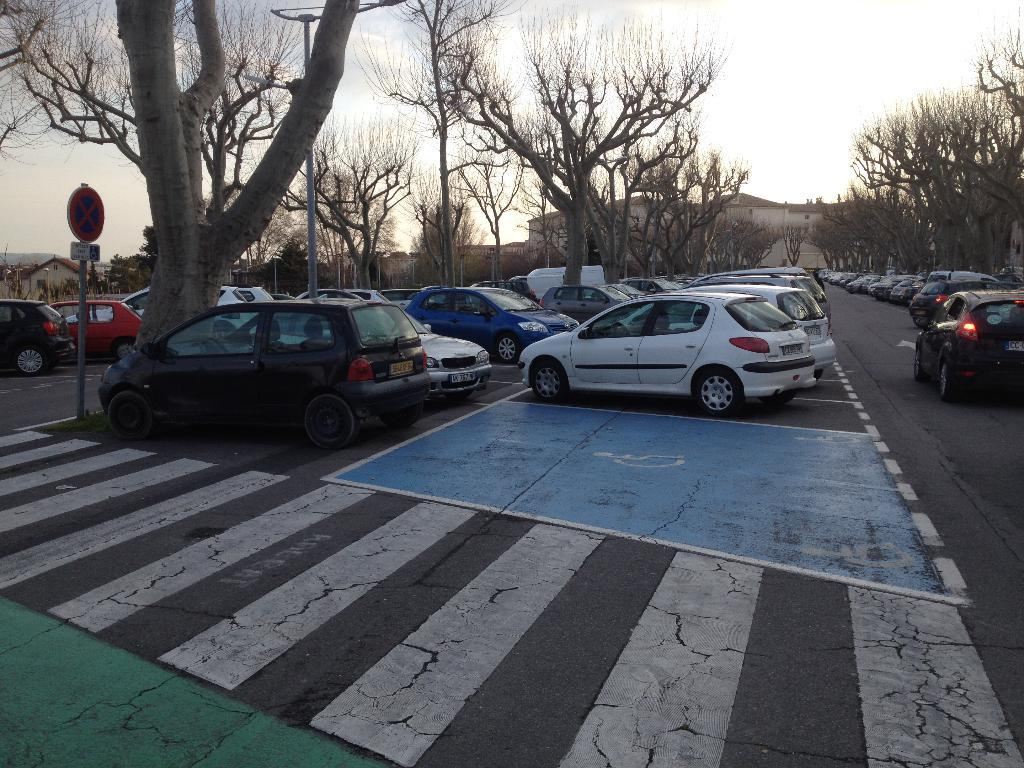What type of structures can be seen in the image? There are buildings in the image. What kind of vegetation is present in the image? Dry trees are present in the image. What are the tall, thin objects in the image? Poles are visible in the image. What type of information might be conveyed by the objects in the image? Signboards are in the image, which might convey information. What is visible in the background of the image? The sky is visible in the image. What type of vehicles can be seen in the image? There are parked vehicles in the image. Can you tell me how many parents are visible in the image? There are no parents present in the image. What type of lock is used to secure the vehicles in the image? There is no lock visible in the image, as it only shows parked vehicles. 